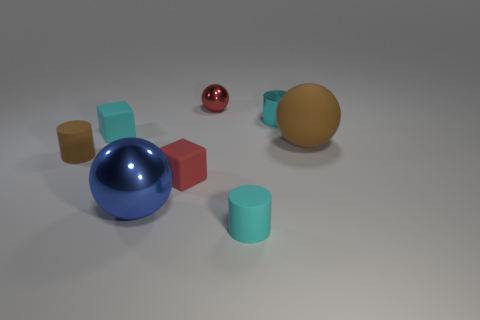Are there an equal number of tiny cyan objects on the right side of the large brown ball and metallic balls behind the large blue object?
Provide a succinct answer. No. The other metal object that is the same shape as the big metallic thing is what color?
Give a very brief answer. Red. Is there any other thing of the same color as the big rubber thing?
Make the answer very short. Yes. What number of rubber objects are either big brown spheres or small cubes?
Offer a terse response. 3. Does the large matte ball have the same color as the small metallic sphere?
Keep it short and to the point. No. Is the number of tiny balls that are behind the blue thing greater than the number of big cyan balls?
Make the answer very short. Yes. What number of other objects are there of the same material as the brown sphere?
Give a very brief answer. 4. What number of tiny things are brown balls or rubber cylinders?
Offer a terse response. 2. Does the large brown sphere have the same material as the red block?
Your answer should be very brief. Yes. There is a brown rubber thing in front of the large brown rubber thing; what number of red metal objects are in front of it?
Your answer should be very brief. 0. 